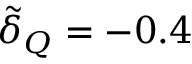<formula> <loc_0><loc_0><loc_500><loc_500>\tilde { \delta } _ { Q } = - 0 . 4</formula> 